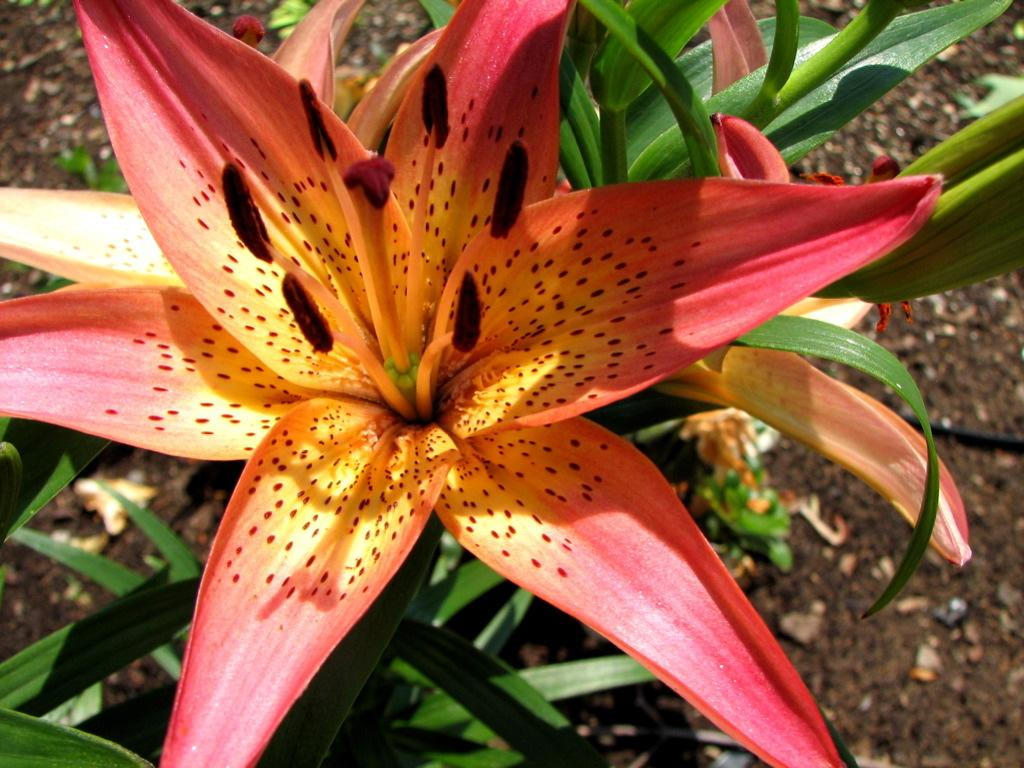What type of living organisms can be seen in the image? Plants can be seen in the image. What specific features do the plants have? The plants have flowers. What colors are the flowers? The flowers are in red and yellow colors. What is the base material for the plants in the image? Soil is visible at the bottom of the image. What type of pie is being served by the grandmother in the image? There is no pie or grandmother present in the image; it only features plants with flowers and soil. 